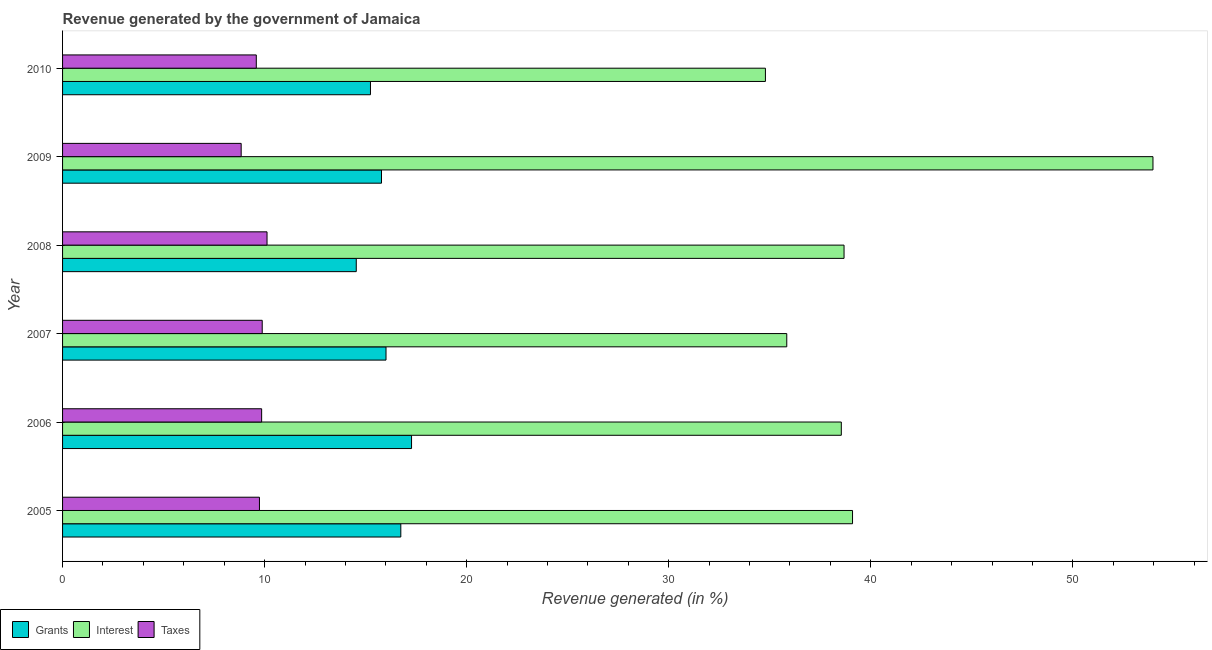How many groups of bars are there?
Offer a very short reply. 6. Are the number of bars per tick equal to the number of legend labels?
Offer a very short reply. Yes. How many bars are there on the 1st tick from the bottom?
Make the answer very short. 3. What is the label of the 3rd group of bars from the top?
Offer a terse response. 2008. In how many cases, is the number of bars for a given year not equal to the number of legend labels?
Provide a succinct answer. 0. What is the percentage of revenue generated by grants in 2009?
Give a very brief answer. 15.78. Across all years, what is the maximum percentage of revenue generated by interest?
Keep it short and to the point. 53.97. Across all years, what is the minimum percentage of revenue generated by interest?
Provide a succinct answer. 34.79. In which year was the percentage of revenue generated by interest maximum?
Your answer should be very brief. 2009. What is the total percentage of revenue generated by taxes in the graph?
Ensure brevity in your answer.  58.02. What is the difference between the percentage of revenue generated by interest in 2006 and that in 2008?
Offer a very short reply. -0.14. What is the difference between the percentage of revenue generated by grants in 2006 and the percentage of revenue generated by interest in 2009?
Offer a very short reply. -36.69. What is the average percentage of revenue generated by taxes per year?
Provide a succinct answer. 9.67. In the year 2006, what is the difference between the percentage of revenue generated by grants and percentage of revenue generated by interest?
Offer a terse response. -21.27. In how many years, is the percentage of revenue generated by grants greater than 28 %?
Your answer should be compact. 0. Is the percentage of revenue generated by interest in 2007 less than that in 2008?
Your response must be concise. Yes. Is the difference between the percentage of revenue generated by grants in 2006 and 2007 greater than the difference between the percentage of revenue generated by interest in 2006 and 2007?
Keep it short and to the point. No. What is the difference between the highest and the second highest percentage of revenue generated by interest?
Offer a terse response. 14.87. What is the difference between the highest and the lowest percentage of revenue generated by interest?
Make the answer very short. 19.18. In how many years, is the percentage of revenue generated by grants greater than the average percentage of revenue generated by grants taken over all years?
Make the answer very short. 3. Is the sum of the percentage of revenue generated by interest in 2005 and 2007 greater than the maximum percentage of revenue generated by taxes across all years?
Offer a very short reply. Yes. What does the 2nd bar from the top in 2007 represents?
Your answer should be compact. Interest. What does the 3rd bar from the bottom in 2009 represents?
Ensure brevity in your answer.  Taxes. How many bars are there?
Provide a short and direct response. 18. Are the values on the major ticks of X-axis written in scientific E-notation?
Offer a very short reply. No. Does the graph contain any zero values?
Give a very brief answer. No. How many legend labels are there?
Keep it short and to the point. 3. How are the legend labels stacked?
Provide a short and direct response. Horizontal. What is the title of the graph?
Give a very brief answer. Revenue generated by the government of Jamaica. Does "Infant(male)" appear as one of the legend labels in the graph?
Give a very brief answer. No. What is the label or title of the X-axis?
Make the answer very short. Revenue generated (in %). What is the Revenue generated (in %) of Grants in 2005?
Your answer should be very brief. 16.74. What is the Revenue generated (in %) in Interest in 2005?
Make the answer very short. 39.1. What is the Revenue generated (in %) in Taxes in 2005?
Your answer should be very brief. 9.74. What is the Revenue generated (in %) in Grants in 2006?
Provide a succinct answer. 17.27. What is the Revenue generated (in %) of Interest in 2006?
Provide a short and direct response. 38.54. What is the Revenue generated (in %) of Taxes in 2006?
Your answer should be compact. 9.85. What is the Revenue generated (in %) of Grants in 2007?
Offer a terse response. 16.01. What is the Revenue generated (in %) of Interest in 2007?
Provide a short and direct response. 35.84. What is the Revenue generated (in %) in Taxes in 2007?
Ensure brevity in your answer.  9.88. What is the Revenue generated (in %) in Grants in 2008?
Make the answer very short. 14.54. What is the Revenue generated (in %) in Interest in 2008?
Your answer should be compact. 38.68. What is the Revenue generated (in %) in Taxes in 2008?
Ensure brevity in your answer.  10.12. What is the Revenue generated (in %) of Grants in 2009?
Offer a very short reply. 15.78. What is the Revenue generated (in %) of Interest in 2009?
Offer a very short reply. 53.97. What is the Revenue generated (in %) of Taxes in 2009?
Your response must be concise. 8.84. What is the Revenue generated (in %) in Grants in 2010?
Provide a succinct answer. 15.24. What is the Revenue generated (in %) in Interest in 2010?
Offer a terse response. 34.79. What is the Revenue generated (in %) of Taxes in 2010?
Keep it short and to the point. 9.59. Across all years, what is the maximum Revenue generated (in %) in Grants?
Give a very brief answer. 17.27. Across all years, what is the maximum Revenue generated (in %) in Interest?
Ensure brevity in your answer.  53.97. Across all years, what is the maximum Revenue generated (in %) of Taxes?
Provide a short and direct response. 10.12. Across all years, what is the minimum Revenue generated (in %) in Grants?
Your response must be concise. 14.54. Across all years, what is the minimum Revenue generated (in %) of Interest?
Your response must be concise. 34.79. Across all years, what is the minimum Revenue generated (in %) of Taxes?
Your response must be concise. 8.84. What is the total Revenue generated (in %) of Grants in the graph?
Make the answer very short. 95.58. What is the total Revenue generated (in %) in Interest in the graph?
Provide a short and direct response. 240.91. What is the total Revenue generated (in %) in Taxes in the graph?
Make the answer very short. 58.02. What is the difference between the Revenue generated (in %) in Grants in 2005 and that in 2006?
Offer a very short reply. -0.53. What is the difference between the Revenue generated (in %) of Interest in 2005 and that in 2006?
Provide a succinct answer. 0.56. What is the difference between the Revenue generated (in %) in Taxes in 2005 and that in 2006?
Your answer should be very brief. -0.11. What is the difference between the Revenue generated (in %) of Grants in 2005 and that in 2007?
Your answer should be compact. 0.73. What is the difference between the Revenue generated (in %) in Interest in 2005 and that in 2007?
Offer a very short reply. 3.25. What is the difference between the Revenue generated (in %) in Taxes in 2005 and that in 2007?
Make the answer very short. -0.14. What is the difference between the Revenue generated (in %) of Grants in 2005 and that in 2008?
Your response must be concise. 2.2. What is the difference between the Revenue generated (in %) of Interest in 2005 and that in 2008?
Ensure brevity in your answer.  0.42. What is the difference between the Revenue generated (in %) of Taxes in 2005 and that in 2008?
Ensure brevity in your answer.  -0.38. What is the difference between the Revenue generated (in %) in Grants in 2005 and that in 2009?
Provide a succinct answer. 0.96. What is the difference between the Revenue generated (in %) of Interest in 2005 and that in 2009?
Ensure brevity in your answer.  -14.87. What is the difference between the Revenue generated (in %) of Taxes in 2005 and that in 2009?
Your response must be concise. 0.9. What is the difference between the Revenue generated (in %) in Grants in 2005 and that in 2010?
Provide a short and direct response. 1.5. What is the difference between the Revenue generated (in %) in Interest in 2005 and that in 2010?
Make the answer very short. 4.31. What is the difference between the Revenue generated (in %) of Taxes in 2005 and that in 2010?
Your answer should be compact. 0.16. What is the difference between the Revenue generated (in %) of Grants in 2006 and that in 2007?
Your answer should be very brief. 1.26. What is the difference between the Revenue generated (in %) in Interest in 2006 and that in 2007?
Your answer should be very brief. 2.7. What is the difference between the Revenue generated (in %) of Taxes in 2006 and that in 2007?
Provide a short and direct response. -0.03. What is the difference between the Revenue generated (in %) of Grants in 2006 and that in 2008?
Ensure brevity in your answer.  2.74. What is the difference between the Revenue generated (in %) in Interest in 2006 and that in 2008?
Give a very brief answer. -0.14. What is the difference between the Revenue generated (in %) of Taxes in 2006 and that in 2008?
Make the answer very short. -0.27. What is the difference between the Revenue generated (in %) of Grants in 2006 and that in 2009?
Your response must be concise. 1.49. What is the difference between the Revenue generated (in %) in Interest in 2006 and that in 2009?
Offer a very short reply. -15.42. What is the difference between the Revenue generated (in %) of Taxes in 2006 and that in 2009?
Keep it short and to the point. 1.01. What is the difference between the Revenue generated (in %) of Grants in 2006 and that in 2010?
Your answer should be compact. 2.03. What is the difference between the Revenue generated (in %) of Interest in 2006 and that in 2010?
Your response must be concise. 3.76. What is the difference between the Revenue generated (in %) of Taxes in 2006 and that in 2010?
Your response must be concise. 0.26. What is the difference between the Revenue generated (in %) in Grants in 2007 and that in 2008?
Your response must be concise. 1.47. What is the difference between the Revenue generated (in %) of Interest in 2007 and that in 2008?
Ensure brevity in your answer.  -2.83. What is the difference between the Revenue generated (in %) of Taxes in 2007 and that in 2008?
Offer a terse response. -0.24. What is the difference between the Revenue generated (in %) of Grants in 2007 and that in 2009?
Provide a short and direct response. 0.22. What is the difference between the Revenue generated (in %) of Interest in 2007 and that in 2009?
Give a very brief answer. -18.12. What is the difference between the Revenue generated (in %) of Taxes in 2007 and that in 2009?
Make the answer very short. 1.04. What is the difference between the Revenue generated (in %) in Grants in 2007 and that in 2010?
Provide a succinct answer. 0.77. What is the difference between the Revenue generated (in %) in Interest in 2007 and that in 2010?
Offer a terse response. 1.06. What is the difference between the Revenue generated (in %) in Taxes in 2007 and that in 2010?
Give a very brief answer. 0.29. What is the difference between the Revenue generated (in %) of Grants in 2008 and that in 2009?
Make the answer very short. -1.25. What is the difference between the Revenue generated (in %) in Interest in 2008 and that in 2009?
Provide a short and direct response. -15.29. What is the difference between the Revenue generated (in %) of Taxes in 2008 and that in 2009?
Provide a short and direct response. 1.28. What is the difference between the Revenue generated (in %) of Grants in 2008 and that in 2010?
Give a very brief answer. -0.7. What is the difference between the Revenue generated (in %) of Interest in 2008 and that in 2010?
Provide a succinct answer. 3.89. What is the difference between the Revenue generated (in %) of Taxes in 2008 and that in 2010?
Provide a short and direct response. 0.53. What is the difference between the Revenue generated (in %) of Grants in 2009 and that in 2010?
Provide a short and direct response. 0.55. What is the difference between the Revenue generated (in %) of Interest in 2009 and that in 2010?
Provide a succinct answer. 19.18. What is the difference between the Revenue generated (in %) in Taxes in 2009 and that in 2010?
Give a very brief answer. -0.75. What is the difference between the Revenue generated (in %) in Grants in 2005 and the Revenue generated (in %) in Interest in 2006?
Offer a very short reply. -21.8. What is the difference between the Revenue generated (in %) of Grants in 2005 and the Revenue generated (in %) of Taxes in 2006?
Your answer should be very brief. 6.89. What is the difference between the Revenue generated (in %) in Interest in 2005 and the Revenue generated (in %) in Taxes in 2006?
Offer a very short reply. 29.24. What is the difference between the Revenue generated (in %) in Grants in 2005 and the Revenue generated (in %) in Interest in 2007?
Your response must be concise. -19.1. What is the difference between the Revenue generated (in %) in Grants in 2005 and the Revenue generated (in %) in Taxes in 2007?
Offer a very short reply. 6.86. What is the difference between the Revenue generated (in %) in Interest in 2005 and the Revenue generated (in %) in Taxes in 2007?
Give a very brief answer. 29.21. What is the difference between the Revenue generated (in %) of Grants in 2005 and the Revenue generated (in %) of Interest in 2008?
Provide a succinct answer. -21.94. What is the difference between the Revenue generated (in %) in Grants in 2005 and the Revenue generated (in %) in Taxes in 2008?
Keep it short and to the point. 6.62. What is the difference between the Revenue generated (in %) in Interest in 2005 and the Revenue generated (in %) in Taxes in 2008?
Offer a terse response. 28.98. What is the difference between the Revenue generated (in %) in Grants in 2005 and the Revenue generated (in %) in Interest in 2009?
Give a very brief answer. -37.23. What is the difference between the Revenue generated (in %) of Grants in 2005 and the Revenue generated (in %) of Taxes in 2009?
Ensure brevity in your answer.  7.9. What is the difference between the Revenue generated (in %) in Interest in 2005 and the Revenue generated (in %) in Taxes in 2009?
Offer a very short reply. 30.26. What is the difference between the Revenue generated (in %) of Grants in 2005 and the Revenue generated (in %) of Interest in 2010?
Keep it short and to the point. -18.05. What is the difference between the Revenue generated (in %) of Grants in 2005 and the Revenue generated (in %) of Taxes in 2010?
Your answer should be compact. 7.15. What is the difference between the Revenue generated (in %) in Interest in 2005 and the Revenue generated (in %) in Taxes in 2010?
Offer a very short reply. 29.51. What is the difference between the Revenue generated (in %) in Grants in 2006 and the Revenue generated (in %) in Interest in 2007?
Your response must be concise. -18.57. What is the difference between the Revenue generated (in %) in Grants in 2006 and the Revenue generated (in %) in Taxes in 2007?
Provide a short and direct response. 7.39. What is the difference between the Revenue generated (in %) of Interest in 2006 and the Revenue generated (in %) of Taxes in 2007?
Offer a terse response. 28.66. What is the difference between the Revenue generated (in %) of Grants in 2006 and the Revenue generated (in %) of Interest in 2008?
Provide a succinct answer. -21.4. What is the difference between the Revenue generated (in %) in Grants in 2006 and the Revenue generated (in %) in Taxes in 2008?
Your answer should be very brief. 7.15. What is the difference between the Revenue generated (in %) in Interest in 2006 and the Revenue generated (in %) in Taxes in 2008?
Your answer should be very brief. 28.42. What is the difference between the Revenue generated (in %) in Grants in 2006 and the Revenue generated (in %) in Interest in 2009?
Offer a terse response. -36.69. What is the difference between the Revenue generated (in %) of Grants in 2006 and the Revenue generated (in %) of Taxes in 2009?
Your response must be concise. 8.43. What is the difference between the Revenue generated (in %) in Interest in 2006 and the Revenue generated (in %) in Taxes in 2009?
Your answer should be compact. 29.7. What is the difference between the Revenue generated (in %) of Grants in 2006 and the Revenue generated (in %) of Interest in 2010?
Offer a very short reply. -17.51. What is the difference between the Revenue generated (in %) in Grants in 2006 and the Revenue generated (in %) in Taxes in 2010?
Your answer should be compact. 7.68. What is the difference between the Revenue generated (in %) in Interest in 2006 and the Revenue generated (in %) in Taxes in 2010?
Your answer should be very brief. 28.95. What is the difference between the Revenue generated (in %) of Grants in 2007 and the Revenue generated (in %) of Interest in 2008?
Offer a terse response. -22.67. What is the difference between the Revenue generated (in %) of Grants in 2007 and the Revenue generated (in %) of Taxes in 2008?
Your answer should be very brief. 5.89. What is the difference between the Revenue generated (in %) in Interest in 2007 and the Revenue generated (in %) in Taxes in 2008?
Keep it short and to the point. 25.72. What is the difference between the Revenue generated (in %) of Grants in 2007 and the Revenue generated (in %) of Interest in 2009?
Make the answer very short. -37.96. What is the difference between the Revenue generated (in %) of Grants in 2007 and the Revenue generated (in %) of Taxes in 2009?
Your answer should be very brief. 7.17. What is the difference between the Revenue generated (in %) in Interest in 2007 and the Revenue generated (in %) in Taxes in 2009?
Make the answer very short. 27. What is the difference between the Revenue generated (in %) in Grants in 2007 and the Revenue generated (in %) in Interest in 2010?
Your answer should be very brief. -18.78. What is the difference between the Revenue generated (in %) of Grants in 2007 and the Revenue generated (in %) of Taxes in 2010?
Make the answer very short. 6.42. What is the difference between the Revenue generated (in %) of Interest in 2007 and the Revenue generated (in %) of Taxes in 2010?
Offer a terse response. 26.25. What is the difference between the Revenue generated (in %) in Grants in 2008 and the Revenue generated (in %) in Interest in 2009?
Offer a terse response. -39.43. What is the difference between the Revenue generated (in %) in Grants in 2008 and the Revenue generated (in %) in Taxes in 2009?
Provide a short and direct response. 5.7. What is the difference between the Revenue generated (in %) in Interest in 2008 and the Revenue generated (in %) in Taxes in 2009?
Provide a succinct answer. 29.84. What is the difference between the Revenue generated (in %) of Grants in 2008 and the Revenue generated (in %) of Interest in 2010?
Offer a terse response. -20.25. What is the difference between the Revenue generated (in %) in Grants in 2008 and the Revenue generated (in %) in Taxes in 2010?
Give a very brief answer. 4.95. What is the difference between the Revenue generated (in %) in Interest in 2008 and the Revenue generated (in %) in Taxes in 2010?
Your response must be concise. 29.09. What is the difference between the Revenue generated (in %) in Grants in 2009 and the Revenue generated (in %) in Interest in 2010?
Your answer should be very brief. -19. What is the difference between the Revenue generated (in %) of Grants in 2009 and the Revenue generated (in %) of Taxes in 2010?
Provide a succinct answer. 6.2. What is the difference between the Revenue generated (in %) in Interest in 2009 and the Revenue generated (in %) in Taxes in 2010?
Keep it short and to the point. 44.38. What is the average Revenue generated (in %) of Grants per year?
Provide a succinct answer. 15.93. What is the average Revenue generated (in %) of Interest per year?
Your answer should be compact. 40.15. What is the average Revenue generated (in %) of Taxes per year?
Give a very brief answer. 9.67. In the year 2005, what is the difference between the Revenue generated (in %) in Grants and Revenue generated (in %) in Interest?
Offer a terse response. -22.36. In the year 2005, what is the difference between the Revenue generated (in %) in Grants and Revenue generated (in %) in Taxes?
Give a very brief answer. 7. In the year 2005, what is the difference between the Revenue generated (in %) in Interest and Revenue generated (in %) in Taxes?
Keep it short and to the point. 29.35. In the year 2006, what is the difference between the Revenue generated (in %) of Grants and Revenue generated (in %) of Interest?
Your response must be concise. -21.27. In the year 2006, what is the difference between the Revenue generated (in %) of Grants and Revenue generated (in %) of Taxes?
Offer a very short reply. 7.42. In the year 2006, what is the difference between the Revenue generated (in %) of Interest and Revenue generated (in %) of Taxes?
Provide a short and direct response. 28.69. In the year 2007, what is the difference between the Revenue generated (in %) of Grants and Revenue generated (in %) of Interest?
Your answer should be compact. -19.83. In the year 2007, what is the difference between the Revenue generated (in %) in Grants and Revenue generated (in %) in Taxes?
Provide a short and direct response. 6.13. In the year 2007, what is the difference between the Revenue generated (in %) of Interest and Revenue generated (in %) of Taxes?
Your answer should be very brief. 25.96. In the year 2008, what is the difference between the Revenue generated (in %) in Grants and Revenue generated (in %) in Interest?
Provide a short and direct response. -24.14. In the year 2008, what is the difference between the Revenue generated (in %) of Grants and Revenue generated (in %) of Taxes?
Offer a very short reply. 4.42. In the year 2008, what is the difference between the Revenue generated (in %) in Interest and Revenue generated (in %) in Taxes?
Ensure brevity in your answer.  28.56. In the year 2009, what is the difference between the Revenue generated (in %) of Grants and Revenue generated (in %) of Interest?
Offer a terse response. -38.18. In the year 2009, what is the difference between the Revenue generated (in %) in Grants and Revenue generated (in %) in Taxes?
Offer a very short reply. 6.94. In the year 2009, what is the difference between the Revenue generated (in %) in Interest and Revenue generated (in %) in Taxes?
Offer a terse response. 45.13. In the year 2010, what is the difference between the Revenue generated (in %) in Grants and Revenue generated (in %) in Interest?
Provide a short and direct response. -19.55. In the year 2010, what is the difference between the Revenue generated (in %) of Grants and Revenue generated (in %) of Taxes?
Provide a succinct answer. 5.65. In the year 2010, what is the difference between the Revenue generated (in %) of Interest and Revenue generated (in %) of Taxes?
Provide a succinct answer. 25.2. What is the ratio of the Revenue generated (in %) in Grants in 2005 to that in 2006?
Provide a succinct answer. 0.97. What is the ratio of the Revenue generated (in %) in Interest in 2005 to that in 2006?
Give a very brief answer. 1.01. What is the ratio of the Revenue generated (in %) of Taxes in 2005 to that in 2006?
Make the answer very short. 0.99. What is the ratio of the Revenue generated (in %) in Grants in 2005 to that in 2007?
Give a very brief answer. 1.05. What is the ratio of the Revenue generated (in %) in Interest in 2005 to that in 2007?
Offer a terse response. 1.09. What is the ratio of the Revenue generated (in %) in Taxes in 2005 to that in 2007?
Provide a short and direct response. 0.99. What is the ratio of the Revenue generated (in %) of Grants in 2005 to that in 2008?
Keep it short and to the point. 1.15. What is the ratio of the Revenue generated (in %) in Interest in 2005 to that in 2008?
Give a very brief answer. 1.01. What is the ratio of the Revenue generated (in %) of Taxes in 2005 to that in 2008?
Make the answer very short. 0.96. What is the ratio of the Revenue generated (in %) of Grants in 2005 to that in 2009?
Provide a short and direct response. 1.06. What is the ratio of the Revenue generated (in %) of Interest in 2005 to that in 2009?
Give a very brief answer. 0.72. What is the ratio of the Revenue generated (in %) in Taxes in 2005 to that in 2009?
Make the answer very short. 1.1. What is the ratio of the Revenue generated (in %) of Grants in 2005 to that in 2010?
Offer a very short reply. 1.1. What is the ratio of the Revenue generated (in %) in Interest in 2005 to that in 2010?
Provide a succinct answer. 1.12. What is the ratio of the Revenue generated (in %) in Taxes in 2005 to that in 2010?
Keep it short and to the point. 1.02. What is the ratio of the Revenue generated (in %) of Grants in 2006 to that in 2007?
Your answer should be compact. 1.08. What is the ratio of the Revenue generated (in %) of Interest in 2006 to that in 2007?
Ensure brevity in your answer.  1.08. What is the ratio of the Revenue generated (in %) in Grants in 2006 to that in 2008?
Ensure brevity in your answer.  1.19. What is the ratio of the Revenue generated (in %) in Taxes in 2006 to that in 2008?
Offer a terse response. 0.97. What is the ratio of the Revenue generated (in %) in Grants in 2006 to that in 2009?
Keep it short and to the point. 1.09. What is the ratio of the Revenue generated (in %) of Interest in 2006 to that in 2009?
Make the answer very short. 0.71. What is the ratio of the Revenue generated (in %) of Taxes in 2006 to that in 2009?
Your response must be concise. 1.11. What is the ratio of the Revenue generated (in %) of Grants in 2006 to that in 2010?
Ensure brevity in your answer.  1.13. What is the ratio of the Revenue generated (in %) in Interest in 2006 to that in 2010?
Your answer should be compact. 1.11. What is the ratio of the Revenue generated (in %) in Taxes in 2006 to that in 2010?
Ensure brevity in your answer.  1.03. What is the ratio of the Revenue generated (in %) of Grants in 2007 to that in 2008?
Your response must be concise. 1.1. What is the ratio of the Revenue generated (in %) in Interest in 2007 to that in 2008?
Provide a short and direct response. 0.93. What is the ratio of the Revenue generated (in %) of Taxes in 2007 to that in 2008?
Offer a very short reply. 0.98. What is the ratio of the Revenue generated (in %) of Grants in 2007 to that in 2009?
Provide a succinct answer. 1.01. What is the ratio of the Revenue generated (in %) of Interest in 2007 to that in 2009?
Provide a succinct answer. 0.66. What is the ratio of the Revenue generated (in %) in Taxes in 2007 to that in 2009?
Your response must be concise. 1.12. What is the ratio of the Revenue generated (in %) of Grants in 2007 to that in 2010?
Make the answer very short. 1.05. What is the ratio of the Revenue generated (in %) in Interest in 2007 to that in 2010?
Your answer should be very brief. 1.03. What is the ratio of the Revenue generated (in %) of Taxes in 2007 to that in 2010?
Provide a short and direct response. 1.03. What is the ratio of the Revenue generated (in %) in Grants in 2008 to that in 2009?
Provide a short and direct response. 0.92. What is the ratio of the Revenue generated (in %) in Interest in 2008 to that in 2009?
Keep it short and to the point. 0.72. What is the ratio of the Revenue generated (in %) of Taxes in 2008 to that in 2009?
Your answer should be very brief. 1.14. What is the ratio of the Revenue generated (in %) of Grants in 2008 to that in 2010?
Provide a short and direct response. 0.95. What is the ratio of the Revenue generated (in %) of Interest in 2008 to that in 2010?
Your answer should be compact. 1.11. What is the ratio of the Revenue generated (in %) in Taxes in 2008 to that in 2010?
Your answer should be compact. 1.06. What is the ratio of the Revenue generated (in %) in Grants in 2009 to that in 2010?
Your response must be concise. 1.04. What is the ratio of the Revenue generated (in %) of Interest in 2009 to that in 2010?
Your response must be concise. 1.55. What is the ratio of the Revenue generated (in %) of Taxes in 2009 to that in 2010?
Your answer should be compact. 0.92. What is the difference between the highest and the second highest Revenue generated (in %) of Grants?
Provide a short and direct response. 0.53. What is the difference between the highest and the second highest Revenue generated (in %) in Interest?
Provide a short and direct response. 14.87. What is the difference between the highest and the second highest Revenue generated (in %) of Taxes?
Offer a very short reply. 0.24. What is the difference between the highest and the lowest Revenue generated (in %) of Grants?
Ensure brevity in your answer.  2.74. What is the difference between the highest and the lowest Revenue generated (in %) in Interest?
Ensure brevity in your answer.  19.18. What is the difference between the highest and the lowest Revenue generated (in %) in Taxes?
Make the answer very short. 1.28. 